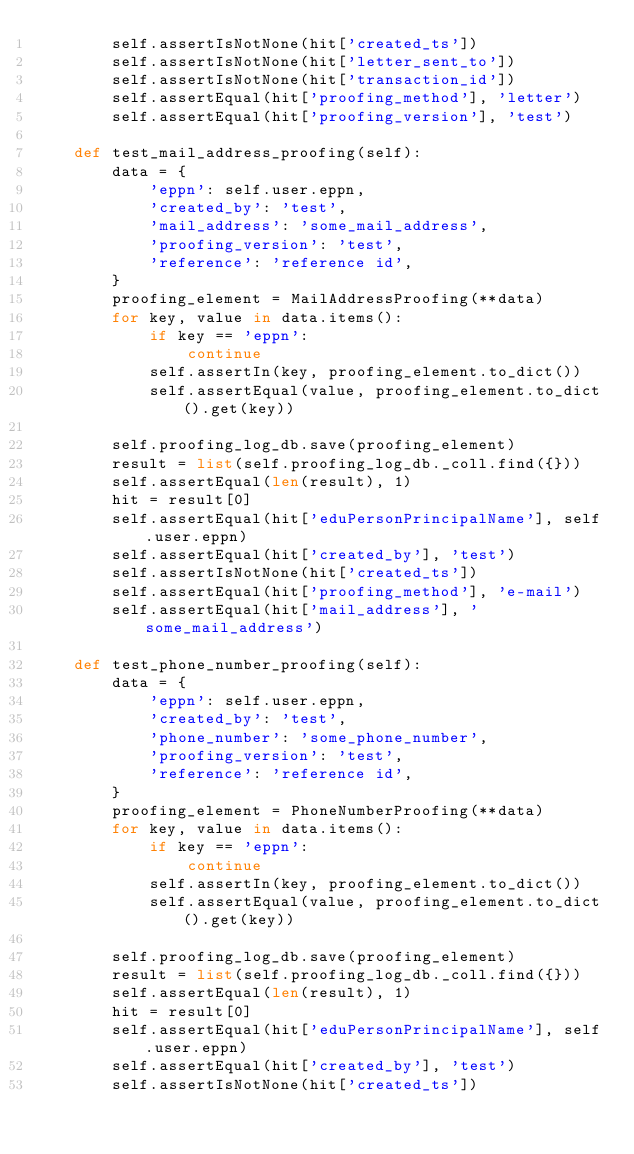Convert code to text. <code><loc_0><loc_0><loc_500><loc_500><_Python_>        self.assertIsNotNone(hit['created_ts'])
        self.assertIsNotNone(hit['letter_sent_to'])
        self.assertIsNotNone(hit['transaction_id'])
        self.assertEqual(hit['proofing_method'], 'letter')
        self.assertEqual(hit['proofing_version'], 'test')

    def test_mail_address_proofing(self):
        data = {
            'eppn': self.user.eppn,
            'created_by': 'test',
            'mail_address': 'some_mail_address',
            'proofing_version': 'test',
            'reference': 'reference id',
        }
        proofing_element = MailAddressProofing(**data)
        for key, value in data.items():
            if key == 'eppn':
                continue
            self.assertIn(key, proofing_element.to_dict())
            self.assertEqual(value, proofing_element.to_dict().get(key))

        self.proofing_log_db.save(proofing_element)
        result = list(self.proofing_log_db._coll.find({}))
        self.assertEqual(len(result), 1)
        hit = result[0]
        self.assertEqual(hit['eduPersonPrincipalName'], self.user.eppn)
        self.assertEqual(hit['created_by'], 'test')
        self.assertIsNotNone(hit['created_ts'])
        self.assertEqual(hit['proofing_method'], 'e-mail')
        self.assertEqual(hit['mail_address'], 'some_mail_address')

    def test_phone_number_proofing(self):
        data = {
            'eppn': self.user.eppn,
            'created_by': 'test',
            'phone_number': 'some_phone_number',
            'proofing_version': 'test',
            'reference': 'reference id',
        }
        proofing_element = PhoneNumberProofing(**data)
        for key, value in data.items():
            if key == 'eppn':
                continue
            self.assertIn(key, proofing_element.to_dict())
            self.assertEqual(value, proofing_element.to_dict().get(key))

        self.proofing_log_db.save(proofing_element)
        result = list(self.proofing_log_db._coll.find({}))
        self.assertEqual(len(result), 1)
        hit = result[0]
        self.assertEqual(hit['eduPersonPrincipalName'], self.user.eppn)
        self.assertEqual(hit['created_by'], 'test')
        self.assertIsNotNone(hit['created_ts'])</code> 